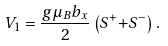<formula> <loc_0><loc_0><loc_500><loc_500>V _ { 1 } = \frac { g \mu _ { B } b _ { x } } { 2 } \left ( S ^ { + } { + } S ^ { - } \right ) .</formula> 